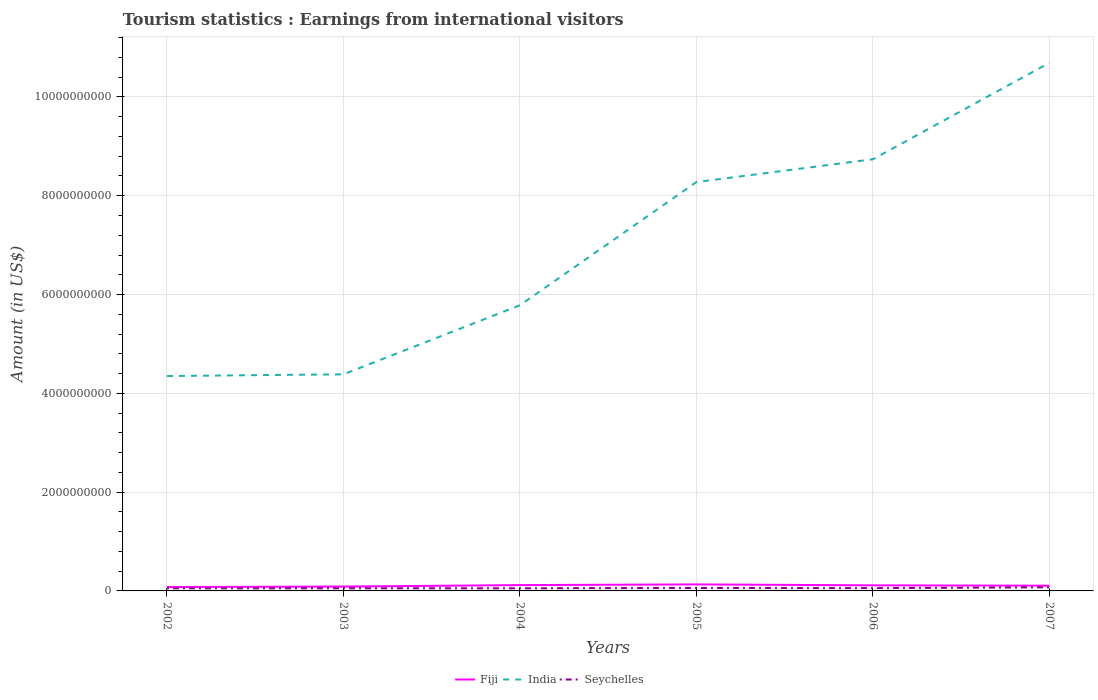Is the number of lines equal to the number of legend labels?
Keep it short and to the point. Yes. Across all years, what is the maximum earnings from international visitors in India?
Provide a succinct answer. 4.35e+09. What is the total earnings from international visitors in Fiji in the graph?
Provide a succinct answer. -3.40e+07. What is the difference between the highest and the second highest earnings from international visitors in Fiji?
Keep it short and to the point. 5.30e+07. What is the difference between the highest and the lowest earnings from international visitors in Fiji?
Your answer should be compact. 3. Is the earnings from international visitors in Fiji strictly greater than the earnings from international visitors in Seychelles over the years?
Your answer should be compact. No. How many years are there in the graph?
Offer a very short reply. 6. What is the difference between two consecutive major ticks on the Y-axis?
Make the answer very short. 2.00e+09. Where does the legend appear in the graph?
Provide a short and direct response. Bottom center. How many legend labels are there?
Give a very brief answer. 3. How are the legend labels stacked?
Offer a terse response. Horizontal. What is the title of the graph?
Provide a succinct answer. Tourism statistics : Earnings from international visitors. What is the label or title of the Y-axis?
Offer a very short reply. Amount (in US$). What is the Amount (in US$) of Fiji in 2002?
Keep it short and to the point. 7.90e+07. What is the Amount (in US$) in India in 2002?
Keep it short and to the point. 4.35e+09. What is the Amount (in US$) in Seychelles in 2002?
Keep it short and to the point. 5.30e+07. What is the Amount (in US$) in Fiji in 2003?
Give a very brief answer. 8.80e+07. What is the Amount (in US$) in India in 2003?
Offer a very short reply. 4.38e+09. What is the Amount (in US$) in Seychelles in 2003?
Your answer should be very brief. 5.40e+07. What is the Amount (in US$) in Fiji in 2004?
Make the answer very short. 1.18e+08. What is the Amount (in US$) in India in 2004?
Provide a succinct answer. 5.78e+09. What is the Amount (in US$) of Seychelles in 2004?
Offer a terse response. 5.30e+07. What is the Amount (in US$) of Fiji in 2005?
Offer a terse response. 1.32e+08. What is the Amount (in US$) of India in 2005?
Offer a very short reply. 8.28e+09. What is the Amount (in US$) in Seychelles in 2005?
Your response must be concise. 5.90e+07. What is the Amount (in US$) in Fiji in 2006?
Your answer should be very brief. 1.13e+08. What is the Amount (in US$) of India in 2006?
Make the answer very short. 8.74e+09. What is the Amount (in US$) in Seychelles in 2006?
Make the answer very short. 5.60e+07. What is the Amount (in US$) of Fiji in 2007?
Make the answer very short. 1.06e+08. What is the Amount (in US$) in India in 2007?
Offer a very short reply. 1.07e+1. What is the Amount (in US$) in Seychelles in 2007?
Your response must be concise. 7.30e+07. Across all years, what is the maximum Amount (in US$) of Fiji?
Offer a very short reply. 1.32e+08. Across all years, what is the maximum Amount (in US$) of India?
Ensure brevity in your answer.  1.07e+1. Across all years, what is the maximum Amount (in US$) in Seychelles?
Offer a terse response. 7.30e+07. Across all years, what is the minimum Amount (in US$) in Fiji?
Your response must be concise. 7.90e+07. Across all years, what is the minimum Amount (in US$) of India?
Your answer should be compact. 4.35e+09. Across all years, what is the minimum Amount (in US$) of Seychelles?
Give a very brief answer. 5.30e+07. What is the total Amount (in US$) of Fiji in the graph?
Your answer should be compact. 6.36e+08. What is the total Amount (in US$) of India in the graph?
Offer a terse response. 4.22e+1. What is the total Amount (in US$) of Seychelles in the graph?
Keep it short and to the point. 3.48e+08. What is the difference between the Amount (in US$) in Fiji in 2002 and that in 2003?
Offer a very short reply. -9.00e+06. What is the difference between the Amount (in US$) in India in 2002 and that in 2003?
Make the answer very short. -3.50e+07. What is the difference between the Amount (in US$) in Fiji in 2002 and that in 2004?
Offer a terse response. -3.90e+07. What is the difference between the Amount (in US$) of India in 2002 and that in 2004?
Your answer should be very brief. -1.43e+09. What is the difference between the Amount (in US$) of Fiji in 2002 and that in 2005?
Provide a succinct answer. -5.30e+07. What is the difference between the Amount (in US$) in India in 2002 and that in 2005?
Your answer should be very brief. -3.93e+09. What is the difference between the Amount (in US$) in Seychelles in 2002 and that in 2005?
Your answer should be very brief. -6.00e+06. What is the difference between the Amount (in US$) in Fiji in 2002 and that in 2006?
Make the answer very short. -3.40e+07. What is the difference between the Amount (in US$) of India in 2002 and that in 2006?
Provide a succinct answer. -4.39e+09. What is the difference between the Amount (in US$) of Fiji in 2002 and that in 2007?
Your answer should be compact. -2.70e+07. What is the difference between the Amount (in US$) of India in 2002 and that in 2007?
Keep it short and to the point. -6.34e+09. What is the difference between the Amount (in US$) in Seychelles in 2002 and that in 2007?
Give a very brief answer. -2.00e+07. What is the difference between the Amount (in US$) of Fiji in 2003 and that in 2004?
Make the answer very short. -3.00e+07. What is the difference between the Amount (in US$) of India in 2003 and that in 2004?
Give a very brief answer. -1.40e+09. What is the difference between the Amount (in US$) in Fiji in 2003 and that in 2005?
Give a very brief answer. -4.40e+07. What is the difference between the Amount (in US$) of India in 2003 and that in 2005?
Make the answer very short. -3.89e+09. What is the difference between the Amount (in US$) of Seychelles in 2003 and that in 2005?
Your response must be concise. -5.00e+06. What is the difference between the Amount (in US$) in Fiji in 2003 and that in 2006?
Provide a succinct answer. -2.50e+07. What is the difference between the Amount (in US$) in India in 2003 and that in 2006?
Provide a succinct answer. -4.35e+09. What is the difference between the Amount (in US$) of Fiji in 2003 and that in 2007?
Your answer should be compact. -1.80e+07. What is the difference between the Amount (in US$) of India in 2003 and that in 2007?
Provide a short and direct response. -6.30e+09. What is the difference between the Amount (in US$) in Seychelles in 2003 and that in 2007?
Provide a short and direct response. -1.90e+07. What is the difference between the Amount (in US$) of Fiji in 2004 and that in 2005?
Ensure brevity in your answer.  -1.40e+07. What is the difference between the Amount (in US$) of India in 2004 and that in 2005?
Make the answer very short. -2.49e+09. What is the difference between the Amount (in US$) in Seychelles in 2004 and that in 2005?
Offer a very short reply. -6.00e+06. What is the difference between the Amount (in US$) in Fiji in 2004 and that in 2006?
Your response must be concise. 5.00e+06. What is the difference between the Amount (in US$) of India in 2004 and that in 2006?
Give a very brief answer. -2.96e+09. What is the difference between the Amount (in US$) in Seychelles in 2004 and that in 2006?
Give a very brief answer. -3.00e+06. What is the difference between the Amount (in US$) in Fiji in 2004 and that in 2007?
Make the answer very short. 1.20e+07. What is the difference between the Amount (in US$) in India in 2004 and that in 2007?
Your response must be concise. -4.91e+09. What is the difference between the Amount (in US$) in Seychelles in 2004 and that in 2007?
Keep it short and to the point. -2.00e+07. What is the difference between the Amount (in US$) of Fiji in 2005 and that in 2006?
Offer a terse response. 1.90e+07. What is the difference between the Amount (in US$) in India in 2005 and that in 2006?
Your answer should be compact. -4.61e+08. What is the difference between the Amount (in US$) in Seychelles in 2005 and that in 2006?
Offer a terse response. 3.00e+06. What is the difference between the Amount (in US$) of Fiji in 2005 and that in 2007?
Give a very brief answer. 2.60e+07. What is the difference between the Amount (in US$) of India in 2005 and that in 2007?
Your response must be concise. -2.41e+09. What is the difference between the Amount (in US$) in Seychelles in 2005 and that in 2007?
Ensure brevity in your answer.  -1.40e+07. What is the difference between the Amount (in US$) in Fiji in 2006 and that in 2007?
Provide a short and direct response. 7.00e+06. What is the difference between the Amount (in US$) of India in 2006 and that in 2007?
Provide a succinct answer. -1.95e+09. What is the difference between the Amount (in US$) in Seychelles in 2006 and that in 2007?
Provide a short and direct response. -1.70e+07. What is the difference between the Amount (in US$) in Fiji in 2002 and the Amount (in US$) in India in 2003?
Provide a short and direct response. -4.31e+09. What is the difference between the Amount (in US$) in Fiji in 2002 and the Amount (in US$) in Seychelles in 2003?
Provide a short and direct response. 2.50e+07. What is the difference between the Amount (in US$) in India in 2002 and the Amount (in US$) in Seychelles in 2003?
Provide a short and direct response. 4.30e+09. What is the difference between the Amount (in US$) of Fiji in 2002 and the Amount (in US$) of India in 2004?
Offer a terse response. -5.70e+09. What is the difference between the Amount (in US$) in Fiji in 2002 and the Amount (in US$) in Seychelles in 2004?
Keep it short and to the point. 2.60e+07. What is the difference between the Amount (in US$) in India in 2002 and the Amount (in US$) in Seychelles in 2004?
Your answer should be compact. 4.30e+09. What is the difference between the Amount (in US$) in Fiji in 2002 and the Amount (in US$) in India in 2005?
Provide a short and direct response. -8.20e+09. What is the difference between the Amount (in US$) in India in 2002 and the Amount (in US$) in Seychelles in 2005?
Provide a succinct answer. 4.29e+09. What is the difference between the Amount (in US$) in Fiji in 2002 and the Amount (in US$) in India in 2006?
Give a very brief answer. -8.66e+09. What is the difference between the Amount (in US$) of Fiji in 2002 and the Amount (in US$) of Seychelles in 2006?
Provide a succinct answer. 2.30e+07. What is the difference between the Amount (in US$) of India in 2002 and the Amount (in US$) of Seychelles in 2006?
Keep it short and to the point. 4.29e+09. What is the difference between the Amount (in US$) of Fiji in 2002 and the Amount (in US$) of India in 2007?
Your answer should be compact. -1.06e+1. What is the difference between the Amount (in US$) of India in 2002 and the Amount (in US$) of Seychelles in 2007?
Provide a succinct answer. 4.28e+09. What is the difference between the Amount (in US$) of Fiji in 2003 and the Amount (in US$) of India in 2004?
Give a very brief answer. -5.70e+09. What is the difference between the Amount (in US$) in Fiji in 2003 and the Amount (in US$) in Seychelles in 2004?
Offer a very short reply. 3.50e+07. What is the difference between the Amount (in US$) of India in 2003 and the Amount (in US$) of Seychelles in 2004?
Your answer should be very brief. 4.33e+09. What is the difference between the Amount (in US$) in Fiji in 2003 and the Amount (in US$) in India in 2005?
Make the answer very short. -8.19e+09. What is the difference between the Amount (in US$) of Fiji in 2003 and the Amount (in US$) of Seychelles in 2005?
Provide a succinct answer. 2.90e+07. What is the difference between the Amount (in US$) of India in 2003 and the Amount (in US$) of Seychelles in 2005?
Offer a very short reply. 4.33e+09. What is the difference between the Amount (in US$) in Fiji in 2003 and the Amount (in US$) in India in 2006?
Your response must be concise. -8.65e+09. What is the difference between the Amount (in US$) in Fiji in 2003 and the Amount (in US$) in Seychelles in 2006?
Your response must be concise. 3.20e+07. What is the difference between the Amount (in US$) in India in 2003 and the Amount (in US$) in Seychelles in 2006?
Give a very brief answer. 4.33e+09. What is the difference between the Amount (in US$) in Fiji in 2003 and the Amount (in US$) in India in 2007?
Keep it short and to the point. -1.06e+1. What is the difference between the Amount (in US$) of Fiji in 2003 and the Amount (in US$) of Seychelles in 2007?
Provide a succinct answer. 1.50e+07. What is the difference between the Amount (in US$) in India in 2003 and the Amount (in US$) in Seychelles in 2007?
Provide a short and direct response. 4.31e+09. What is the difference between the Amount (in US$) of Fiji in 2004 and the Amount (in US$) of India in 2005?
Your answer should be compact. -8.16e+09. What is the difference between the Amount (in US$) in Fiji in 2004 and the Amount (in US$) in Seychelles in 2005?
Provide a short and direct response. 5.90e+07. What is the difference between the Amount (in US$) of India in 2004 and the Amount (in US$) of Seychelles in 2005?
Provide a short and direct response. 5.72e+09. What is the difference between the Amount (in US$) in Fiji in 2004 and the Amount (in US$) in India in 2006?
Offer a terse response. -8.62e+09. What is the difference between the Amount (in US$) of Fiji in 2004 and the Amount (in US$) of Seychelles in 2006?
Provide a succinct answer. 6.20e+07. What is the difference between the Amount (in US$) in India in 2004 and the Amount (in US$) in Seychelles in 2006?
Keep it short and to the point. 5.73e+09. What is the difference between the Amount (in US$) in Fiji in 2004 and the Amount (in US$) in India in 2007?
Ensure brevity in your answer.  -1.06e+1. What is the difference between the Amount (in US$) of Fiji in 2004 and the Amount (in US$) of Seychelles in 2007?
Provide a succinct answer. 4.50e+07. What is the difference between the Amount (in US$) of India in 2004 and the Amount (in US$) of Seychelles in 2007?
Make the answer very short. 5.71e+09. What is the difference between the Amount (in US$) of Fiji in 2005 and the Amount (in US$) of India in 2006?
Provide a succinct answer. -8.61e+09. What is the difference between the Amount (in US$) in Fiji in 2005 and the Amount (in US$) in Seychelles in 2006?
Provide a short and direct response. 7.60e+07. What is the difference between the Amount (in US$) of India in 2005 and the Amount (in US$) of Seychelles in 2006?
Offer a very short reply. 8.22e+09. What is the difference between the Amount (in US$) in Fiji in 2005 and the Amount (in US$) in India in 2007?
Your response must be concise. -1.06e+1. What is the difference between the Amount (in US$) in Fiji in 2005 and the Amount (in US$) in Seychelles in 2007?
Offer a very short reply. 5.90e+07. What is the difference between the Amount (in US$) of India in 2005 and the Amount (in US$) of Seychelles in 2007?
Provide a short and direct response. 8.20e+09. What is the difference between the Amount (in US$) in Fiji in 2006 and the Amount (in US$) in India in 2007?
Offer a very short reply. -1.06e+1. What is the difference between the Amount (in US$) of Fiji in 2006 and the Amount (in US$) of Seychelles in 2007?
Your response must be concise. 4.00e+07. What is the difference between the Amount (in US$) in India in 2006 and the Amount (in US$) in Seychelles in 2007?
Give a very brief answer. 8.66e+09. What is the average Amount (in US$) in Fiji per year?
Give a very brief answer. 1.06e+08. What is the average Amount (in US$) in India per year?
Keep it short and to the point. 7.04e+09. What is the average Amount (in US$) of Seychelles per year?
Your answer should be compact. 5.80e+07. In the year 2002, what is the difference between the Amount (in US$) of Fiji and Amount (in US$) of India?
Your response must be concise. -4.27e+09. In the year 2002, what is the difference between the Amount (in US$) of Fiji and Amount (in US$) of Seychelles?
Provide a short and direct response. 2.60e+07. In the year 2002, what is the difference between the Amount (in US$) of India and Amount (in US$) of Seychelles?
Offer a terse response. 4.30e+09. In the year 2003, what is the difference between the Amount (in US$) of Fiji and Amount (in US$) of India?
Give a very brief answer. -4.30e+09. In the year 2003, what is the difference between the Amount (in US$) in Fiji and Amount (in US$) in Seychelles?
Your response must be concise. 3.40e+07. In the year 2003, what is the difference between the Amount (in US$) of India and Amount (in US$) of Seychelles?
Ensure brevity in your answer.  4.33e+09. In the year 2004, what is the difference between the Amount (in US$) of Fiji and Amount (in US$) of India?
Your response must be concise. -5.66e+09. In the year 2004, what is the difference between the Amount (in US$) in Fiji and Amount (in US$) in Seychelles?
Provide a succinct answer. 6.50e+07. In the year 2004, what is the difference between the Amount (in US$) in India and Amount (in US$) in Seychelles?
Your response must be concise. 5.73e+09. In the year 2005, what is the difference between the Amount (in US$) of Fiji and Amount (in US$) of India?
Your response must be concise. -8.14e+09. In the year 2005, what is the difference between the Amount (in US$) of Fiji and Amount (in US$) of Seychelles?
Offer a terse response. 7.30e+07. In the year 2005, what is the difference between the Amount (in US$) of India and Amount (in US$) of Seychelles?
Your answer should be very brief. 8.22e+09. In the year 2006, what is the difference between the Amount (in US$) in Fiji and Amount (in US$) in India?
Give a very brief answer. -8.62e+09. In the year 2006, what is the difference between the Amount (in US$) in Fiji and Amount (in US$) in Seychelles?
Give a very brief answer. 5.70e+07. In the year 2006, what is the difference between the Amount (in US$) in India and Amount (in US$) in Seychelles?
Your answer should be very brief. 8.68e+09. In the year 2007, what is the difference between the Amount (in US$) of Fiji and Amount (in US$) of India?
Give a very brief answer. -1.06e+1. In the year 2007, what is the difference between the Amount (in US$) in Fiji and Amount (in US$) in Seychelles?
Your answer should be very brief. 3.30e+07. In the year 2007, what is the difference between the Amount (in US$) of India and Amount (in US$) of Seychelles?
Your answer should be compact. 1.06e+1. What is the ratio of the Amount (in US$) of Fiji in 2002 to that in 2003?
Keep it short and to the point. 0.9. What is the ratio of the Amount (in US$) of Seychelles in 2002 to that in 2003?
Keep it short and to the point. 0.98. What is the ratio of the Amount (in US$) in Fiji in 2002 to that in 2004?
Your response must be concise. 0.67. What is the ratio of the Amount (in US$) in India in 2002 to that in 2004?
Your answer should be compact. 0.75. What is the ratio of the Amount (in US$) in Fiji in 2002 to that in 2005?
Offer a very short reply. 0.6. What is the ratio of the Amount (in US$) of India in 2002 to that in 2005?
Your answer should be very brief. 0.53. What is the ratio of the Amount (in US$) of Seychelles in 2002 to that in 2005?
Ensure brevity in your answer.  0.9. What is the ratio of the Amount (in US$) in Fiji in 2002 to that in 2006?
Make the answer very short. 0.7. What is the ratio of the Amount (in US$) in India in 2002 to that in 2006?
Offer a very short reply. 0.5. What is the ratio of the Amount (in US$) in Seychelles in 2002 to that in 2006?
Provide a short and direct response. 0.95. What is the ratio of the Amount (in US$) of Fiji in 2002 to that in 2007?
Make the answer very short. 0.75. What is the ratio of the Amount (in US$) of India in 2002 to that in 2007?
Offer a terse response. 0.41. What is the ratio of the Amount (in US$) in Seychelles in 2002 to that in 2007?
Ensure brevity in your answer.  0.73. What is the ratio of the Amount (in US$) of Fiji in 2003 to that in 2004?
Your answer should be compact. 0.75. What is the ratio of the Amount (in US$) in India in 2003 to that in 2004?
Ensure brevity in your answer.  0.76. What is the ratio of the Amount (in US$) in Seychelles in 2003 to that in 2004?
Make the answer very short. 1.02. What is the ratio of the Amount (in US$) in Fiji in 2003 to that in 2005?
Keep it short and to the point. 0.67. What is the ratio of the Amount (in US$) in India in 2003 to that in 2005?
Offer a terse response. 0.53. What is the ratio of the Amount (in US$) in Seychelles in 2003 to that in 2005?
Provide a short and direct response. 0.92. What is the ratio of the Amount (in US$) in Fiji in 2003 to that in 2006?
Your answer should be compact. 0.78. What is the ratio of the Amount (in US$) in India in 2003 to that in 2006?
Your answer should be compact. 0.5. What is the ratio of the Amount (in US$) in Fiji in 2003 to that in 2007?
Provide a succinct answer. 0.83. What is the ratio of the Amount (in US$) in India in 2003 to that in 2007?
Make the answer very short. 0.41. What is the ratio of the Amount (in US$) in Seychelles in 2003 to that in 2007?
Your answer should be compact. 0.74. What is the ratio of the Amount (in US$) of Fiji in 2004 to that in 2005?
Offer a terse response. 0.89. What is the ratio of the Amount (in US$) of India in 2004 to that in 2005?
Your answer should be compact. 0.7. What is the ratio of the Amount (in US$) in Seychelles in 2004 to that in 2005?
Your answer should be very brief. 0.9. What is the ratio of the Amount (in US$) in Fiji in 2004 to that in 2006?
Offer a terse response. 1.04. What is the ratio of the Amount (in US$) in India in 2004 to that in 2006?
Offer a terse response. 0.66. What is the ratio of the Amount (in US$) of Seychelles in 2004 to that in 2006?
Provide a succinct answer. 0.95. What is the ratio of the Amount (in US$) in Fiji in 2004 to that in 2007?
Provide a succinct answer. 1.11. What is the ratio of the Amount (in US$) of India in 2004 to that in 2007?
Your answer should be very brief. 0.54. What is the ratio of the Amount (in US$) in Seychelles in 2004 to that in 2007?
Give a very brief answer. 0.73. What is the ratio of the Amount (in US$) in Fiji in 2005 to that in 2006?
Provide a short and direct response. 1.17. What is the ratio of the Amount (in US$) of India in 2005 to that in 2006?
Your answer should be compact. 0.95. What is the ratio of the Amount (in US$) in Seychelles in 2005 to that in 2006?
Provide a succinct answer. 1.05. What is the ratio of the Amount (in US$) in Fiji in 2005 to that in 2007?
Your answer should be very brief. 1.25. What is the ratio of the Amount (in US$) in India in 2005 to that in 2007?
Ensure brevity in your answer.  0.77. What is the ratio of the Amount (in US$) of Seychelles in 2005 to that in 2007?
Provide a short and direct response. 0.81. What is the ratio of the Amount (in US$) in Fiji in 2006 to that in 2007?
Your answer should be compact. 1.07. What is the ratio of the Amount (in US$) of India in 2006 to that in 2007?
Give a very brief answer. 0.82. What is the ratio of the Amount (in US$) in Seychelles in 2006 to that in 2007?
Make the answer very short. 0.77. What is the difference between the highest and the second highest Amount (in US$) in Fiji?
Your answer should be compact. 1.40e+07. What is the difference between the highest and the second highest Amount (in US$) in India?
Keep it short and to the point. 1.95e+09. What is the difference between the highest and the second highest Amount (in US$) in Seychelles?
Keep it short and to the point. 1.40e+07. What is the difference between the highest and the lowest Amount (in US$) of Fiji?
Your answer should be compact. 5.30e+07. What is the difference between the highest and the lowest Amount (in US$) of India?
Give a very brief answer. 6.34e+09. What is the difference between the highest and the lowest Amount (in US$) of Seychelles?
Provide a succinct answer. 2.00e+07. 